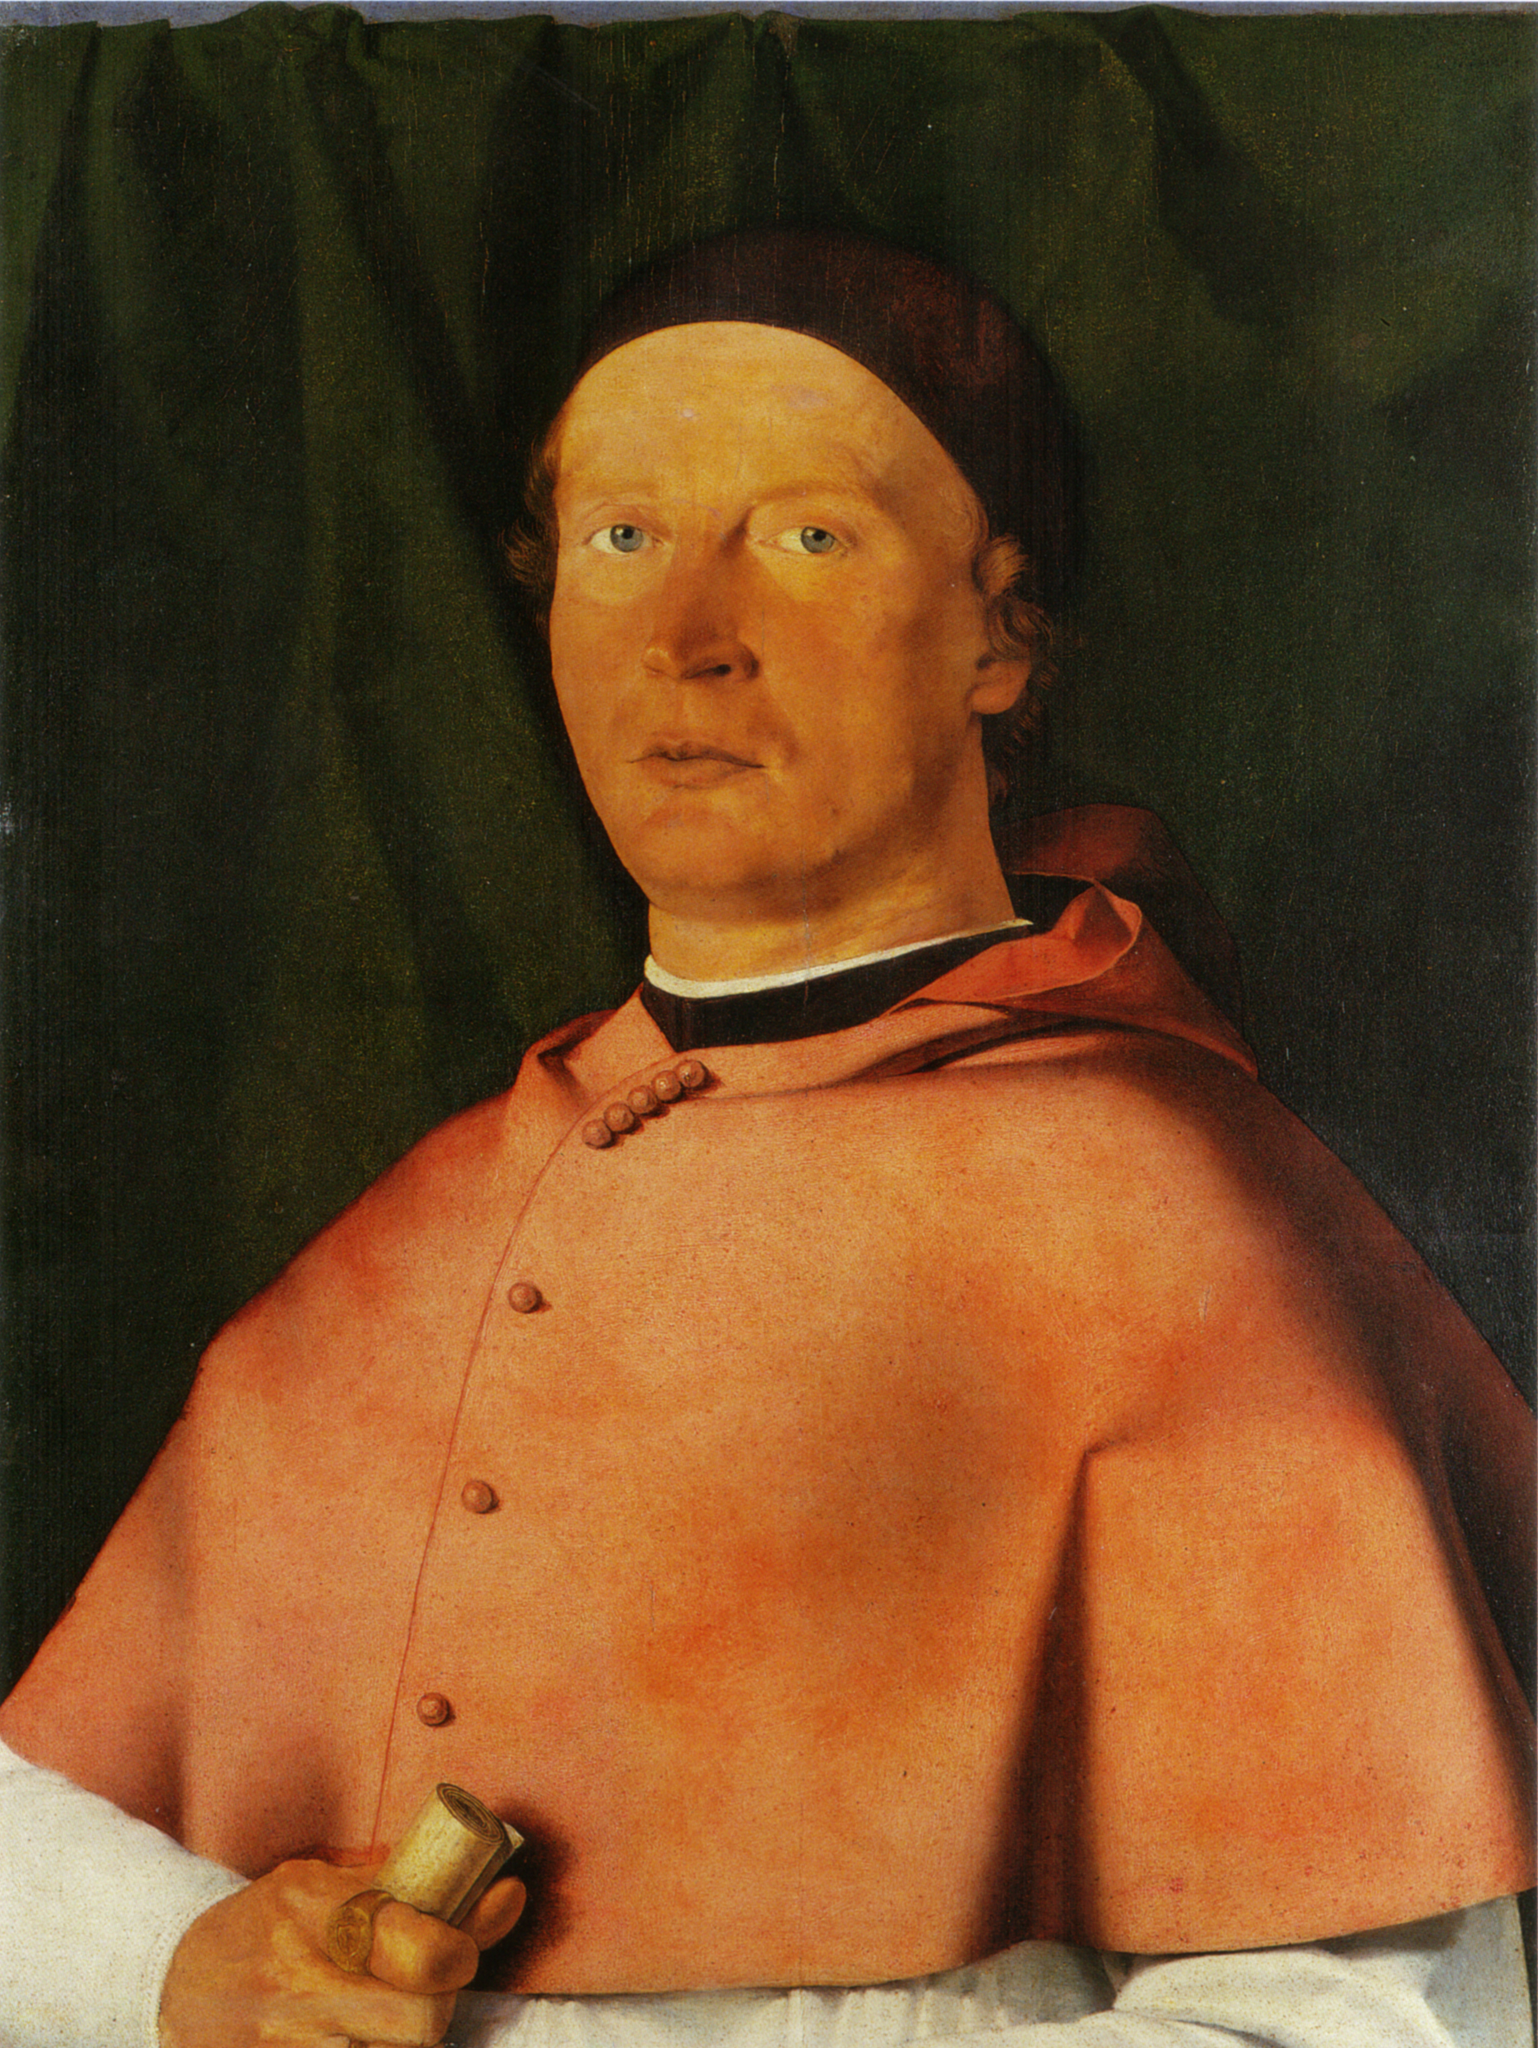Imagine a story where this man is a character. What role does he play and what’s his story? Once upon a time, in a grand city where art and knowledge flourished, there was a distinguished man named Reginald. Known for his wisdom and fair judgments, Reginald served as a chief advisor to the king. He was often seen wearing his bright red robe, symbolizing his high status and unwavering loyalty to the kingdom. The rolled-up document he carried was a map that held the secrets of the ancient cities lost to time. Reginald was on a mission to uncover these secrets to bring prosperity to his land. Every evening, he would work tirelessly by candlelight, deciphering the ancient texts to unlock the mysteries of the old world, ensuring the kingdom's future was secure. 